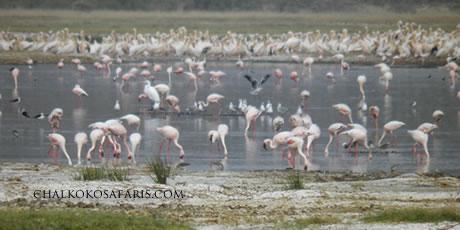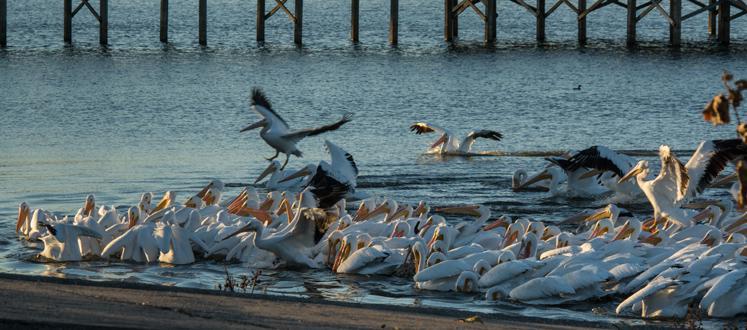The first image is the image on the left, the second image is the image on the right. For the images displayed, is the sentence "In one image, pink flamingos are amassed in water." factually correct? Answer yes or no. Yes. 